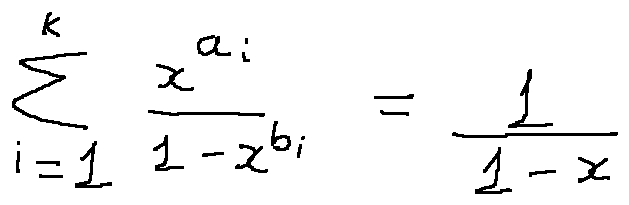<formula> <loc_0><loc_0><loc_500><loc_500>\sum \lim i t s _ { i = 1 } ^ { k } \frac { x ^ { a _ { i } } } { 1 - x ^ { b _ { i } } } = \frac { 1 } { 1 - x }</formula> 